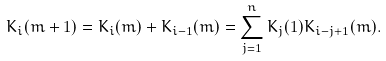<formula> <loc_0><loc_0><loc_500><loc_500>K _ { i } ( m + 1 ) = K _ { i } ( m ) + K _ { i - 1 } ( m ) = \sum _ { j = 1 } ^ { n } K _ { j } ( 1 ) K _ { i - j + 1 } ( m ) .</formula> 